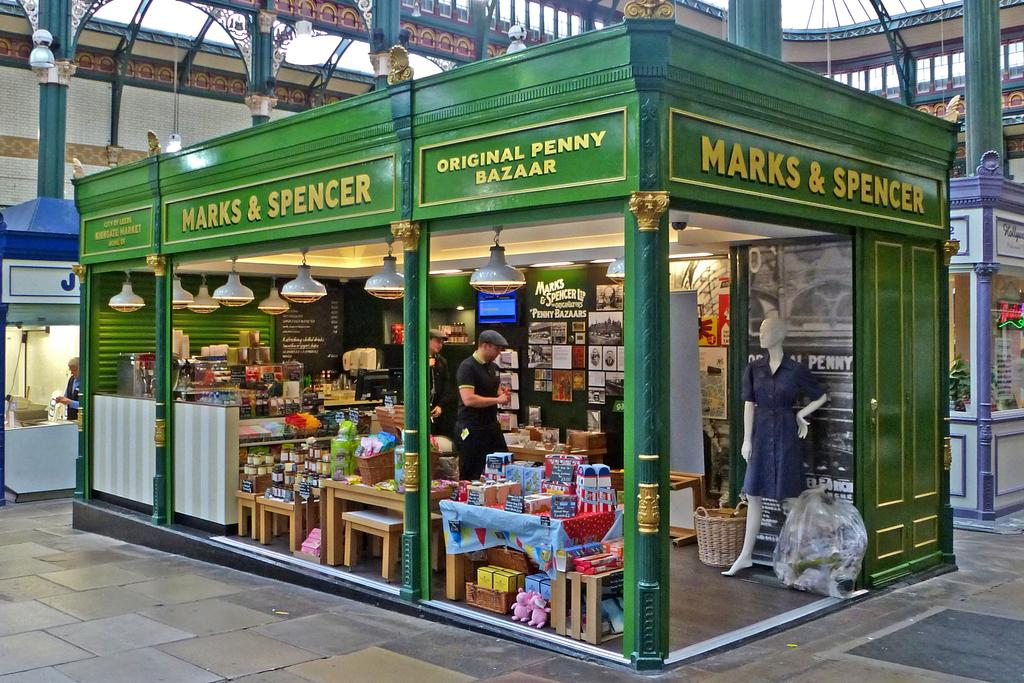Provide a one-sentence caption for the provided image. A very old fashioned looking branch of Marks and Spencer. 